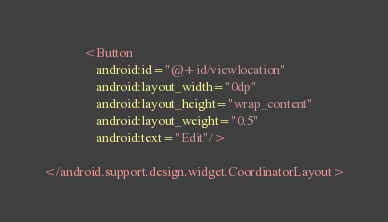<code> <loc_0><loc_0><loc_500><loc_500><_XML_>            <Button
                android:id="@+id/viewlocation"
                android:layout_width="0dp"
                android:layout_height="wrap_content"
                android:layout_weight="0.5"
                android:text="Edit"/>

</android.support.design.widget.CoordinatorLayout>

</code> 